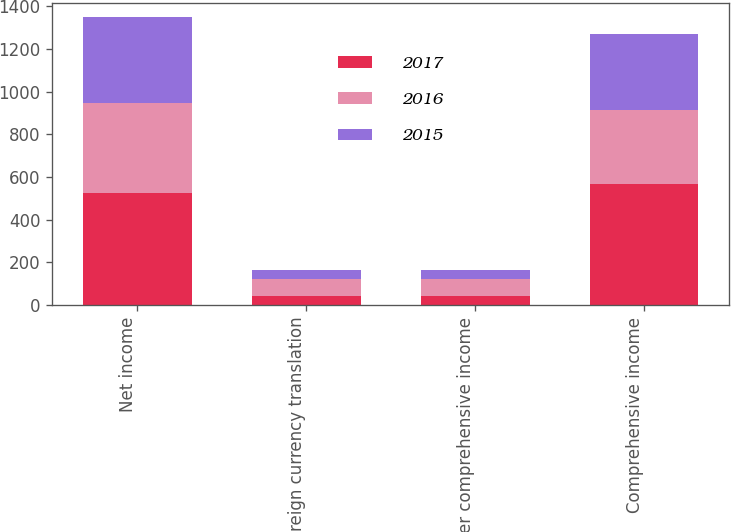Convert chart to OTSL. <chart><loc_0><loc_0><loc_500><loc_500><stacked_bar_chart><ecel><fcel>Net income<fcel>Foreign currency translation<fcel>Other comprehensive income<fcel>Comprehensive income<nl><fcel>2017<fcel>523<fcel>43.5<fcel>43.7<fcel>566.7<nl><fcel>2016<fcel>424.4<fcel>78.5<fcel>78.5<fcel>345.9<nl><fcel>2015<fcel>403.1<fcel>44.5<fcel>44.5<fcel>358.6<nl></chart> 